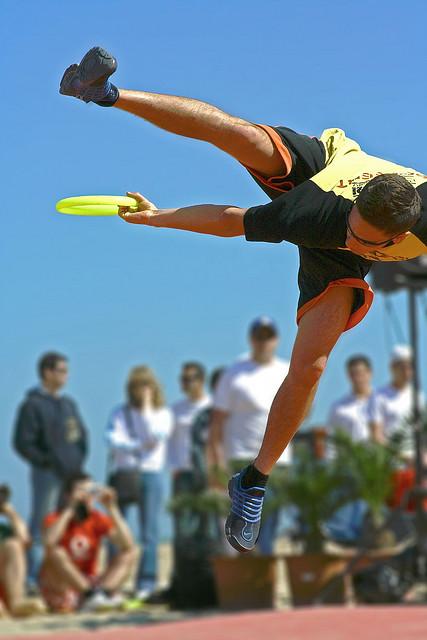Does one need a large space area to play frisbee?
Keep it brief. Yes. What is the man doing?
Be succinct. Catching frisbee. Is the man flying?
Answer briefly. No. What color is the frisbee?
Quick response, please. Yellow. 